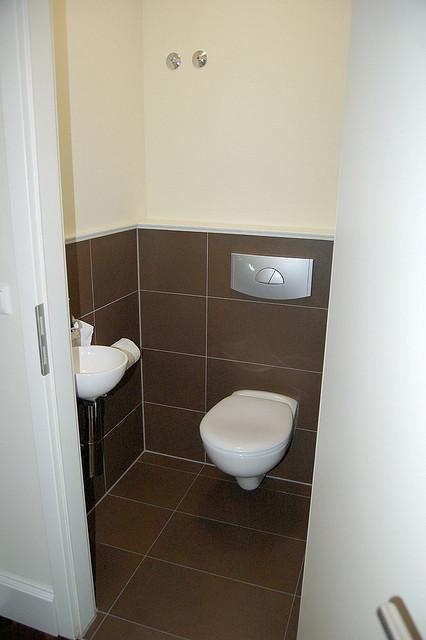How many red cars are there?
Give a very brief answer. 0. 